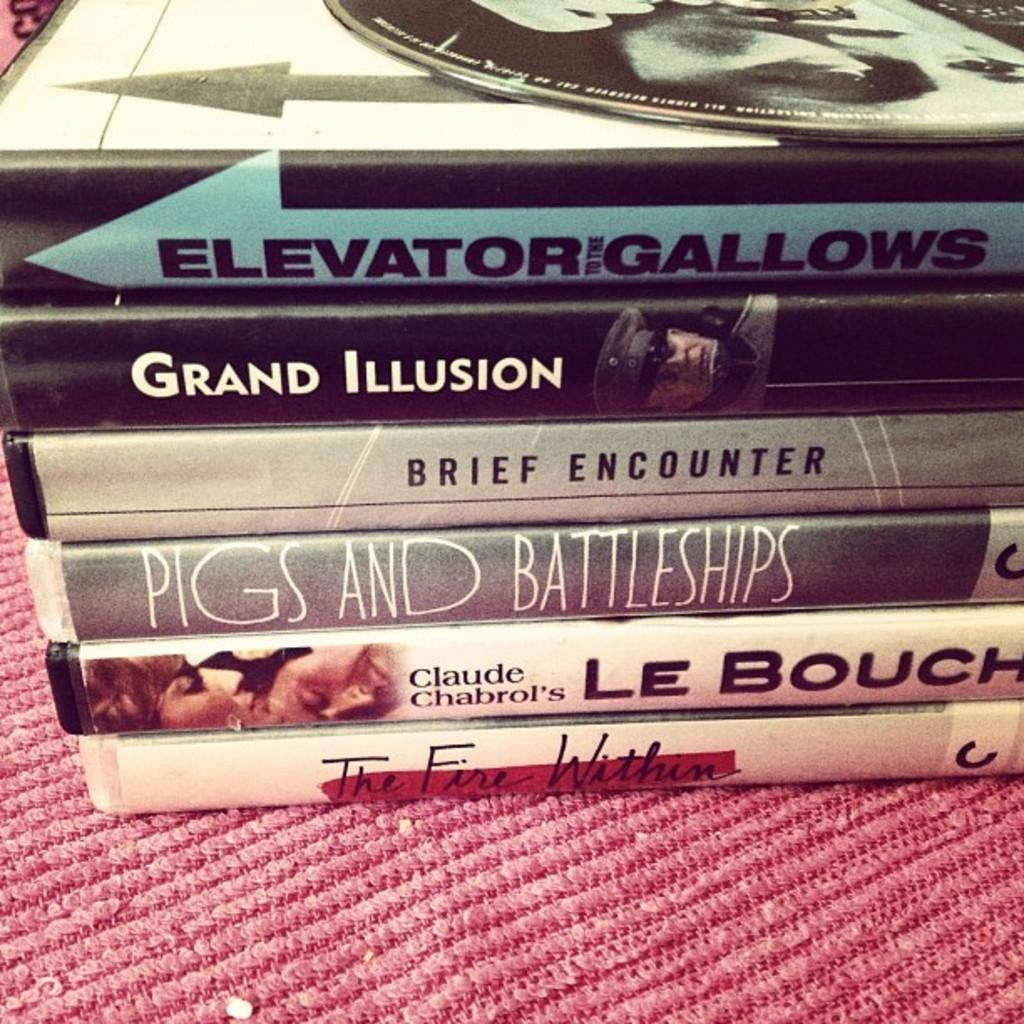Provide a one-sentence caption for the provided image. A couple books titled " Elevator Gallows", " Grand Illusion", and " Brief Encounter". 